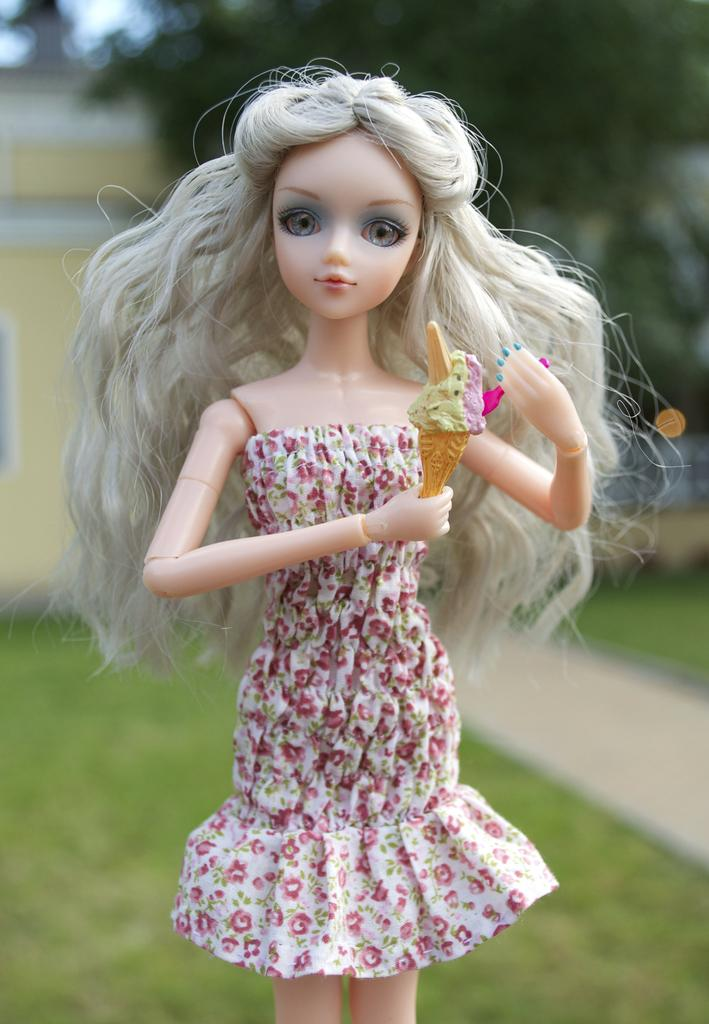What is the main subject in the center of the image? There is a doll in the center of the image. What can be seen in the background of the image? There are trees in the background of the image. What type of surface is visible in the image? There is ground visible in the image. Can you see the moon in the image? No, the moon is not visible in the image. How does the doll pull the tree in the image? The doll does not pull the tree in the image, as there is no interaction between the doll and the trees. 